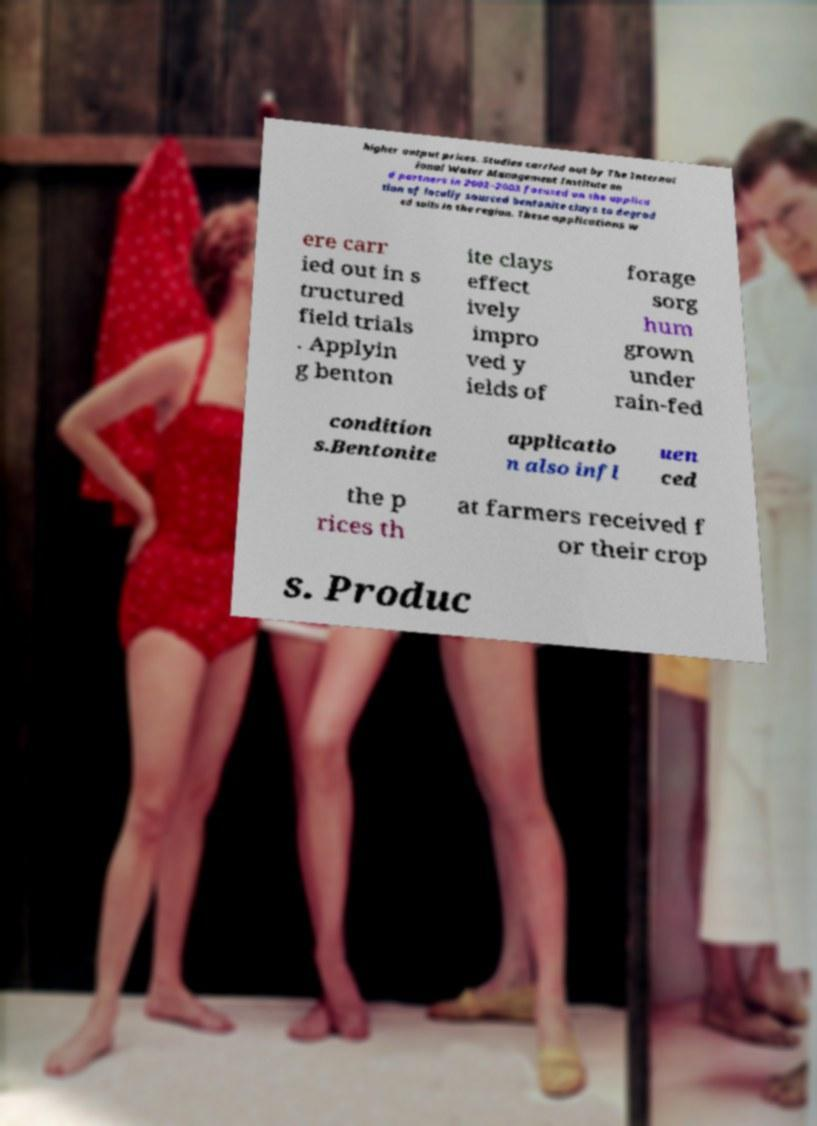What messages or text are displayed in this image? I need them in a readable, typed format. higher output prices. Studies carried out by The Internat ional Water Management Institute an d partners in 2002–2003 focused on the applica tion of locally sourced bentonite clays to degrad ed soils in the region. These applications w ere carr ied out in s tructured field trials . Applyin g benton ite clays effect ively impro ved y ields of forage sorg hum grown under rain-fed condition s.Bentonite applicatio n also infl uen ced the p rices th at farmers received f or their crop s. Produc 